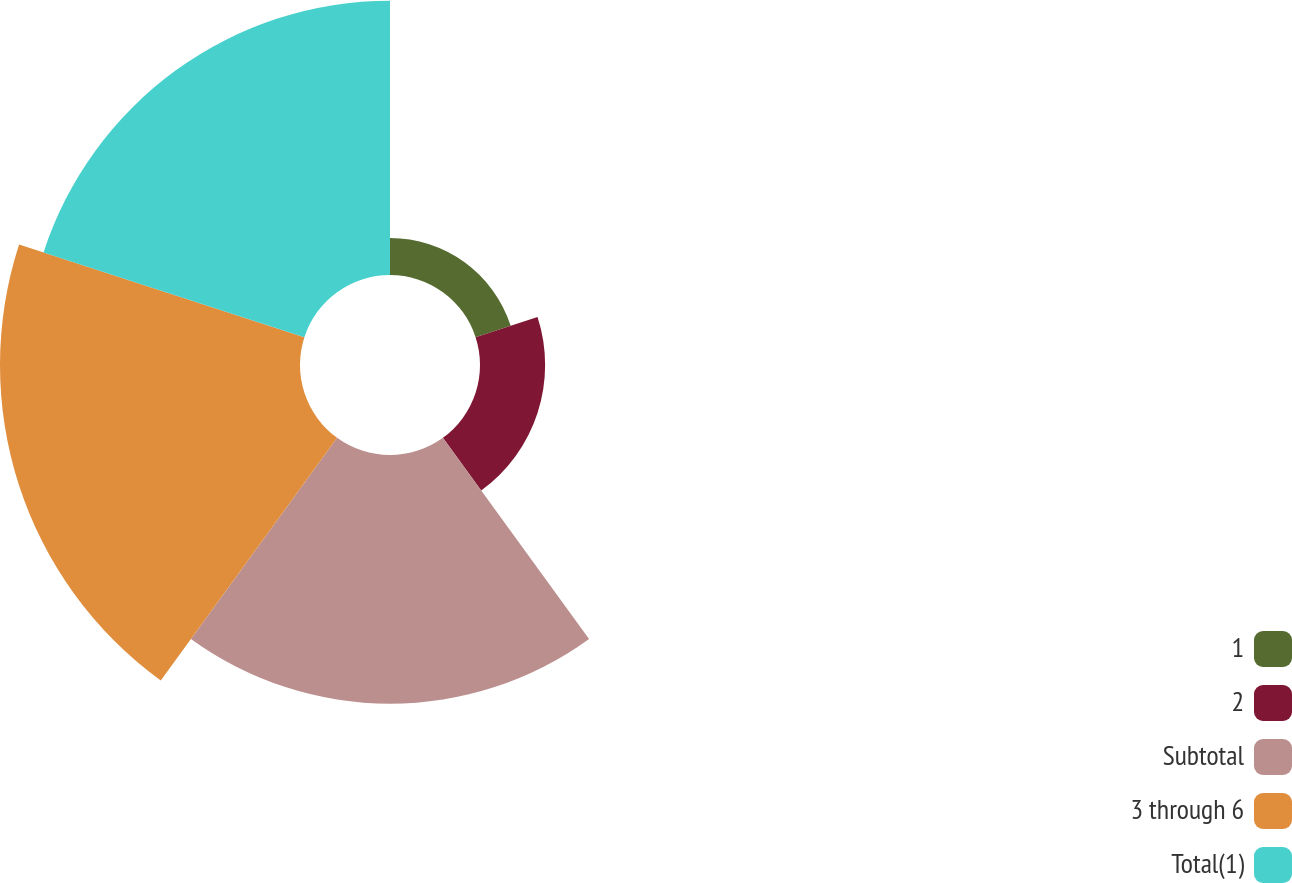Convert chart. <chart><loc_0><loc_0><loc_500><loc_500><pie_chart><fcel>1<fcel>2<fcel>Subtotal<fcel>3 through 6<fcel>Total(1)<nl><fcel>3.99%<fcel>7.04%<fcel>26.88%<fcel>32.43%<fcel>29.65%<nl></chart> 